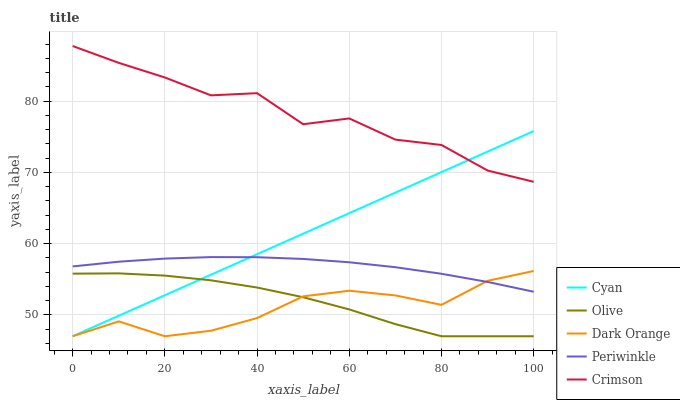Does Dark Orange have the minimum area under the curve?
Answer yes or no. Yes. Does Crimson have the maximum area under the curve?
Answer yes or no. Yes. Does Cyan have the minimum area under the curve?
Answer yes or no. No. Does Cyan have the maximum area under the curve?
Answer yes or no. No. Is Cyan the smoothest?
Answer yes or no. Yes. Is Crimson the roughest?
Answer yes or no. Yes. Is Periwinkle the smoothest?
Answer yes or no. No. Is Periwinkle the roughest?
Answer yes or no. No. Does Periwinkle have the lowest value?
Answer yes or no. No. Does Cyan have the highest value?
Answer yes or no. No. Is Olive less than Periwinkle?
Answer yes or no. Yes. Is Crimson greater than Periwinkle?
Answer yes or no. Yes. Does Olive intersect Periwinkle?
Answer yes or no. No. 